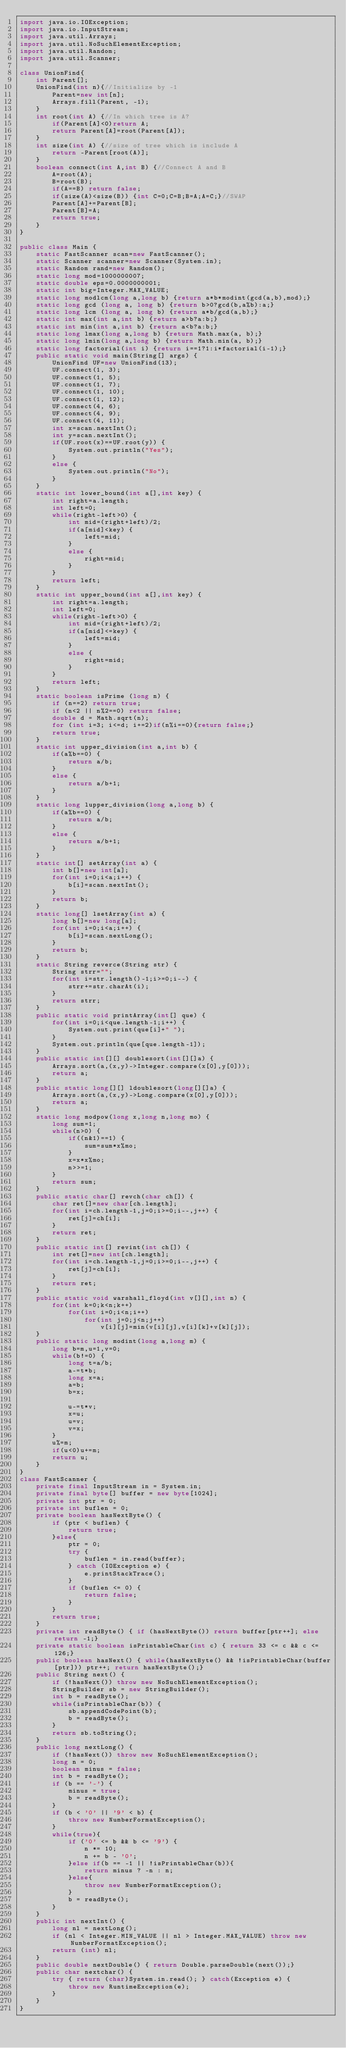<code> <loc_0><loc_0><loc_500><loc_500><_Java_>import java.io.IOException;
import java.io.InputStream;
import java.util.Arrays;
import java.util.NoSuchElementException;
import java.util.Random;
import java.util.Scanner;

class UnionFind{
	int Parent[];
	UnionFind(int n){//Initialize by -1
		Parent=new int[n];
		Arrays.fill(Parent, -1);
	}
	int root(int A) {//In which tree is A?
		if(Parent[A]<0)return A;
		return Parent[A]=root(Parent[A]);
	}
	int size(int A) {//size of tree which is include A
		return -Parent[root(A)];
	}
	boolean connect(int A,int B) {//Connect A and B
		A=root(A);
		B=root(B);
		if(A==B) return false;
		if(size(A)<size(B)) {int C=0;C=B;B=A;A=C;}//SWAP
		Parent[A]+=Parent[B];
		Parent[B]=A;
		return true;
	}
}

public class Main {
	static FastScanner scan=new FastScanner();
	static Scanner scanner=new Scanner(System.in);
	static Random rand=new Random();
	static long mod=1000000007;
	static double eps=0.0000000001;
	static int big=Integer.MAX_VALUE;
	static long modlcm(long a,long b) {return a*b*modint(gcd(a,b),mod);}
	static long gcd (long a, long b) {return b>0?gcd(b,a%b):a;}
	static long lcm (long a, long b) {return a*b/gcd(a,b);}
	static int max(int a,int b) {return a>b?a:b;}
	static int min(int a,int b) {return a<b?a:b;}
	static long lmax(long a,long b) {return Math.max(a, b);}
	static long lmin(long a,long b) {return Math.min(a, b);}
	static long factorial(int i) {return i==1?1:i*factorial(i-1);}
	public static void main(String[] args) {
		UnionFind UF=new UnionFind(13);
		UF.connect(1, 3);
		UF.connect(1, 5);
		UF.connect(1, 7);
		UF.connect(1, 10);
		UF.connect(1, 12);
		UF.connect(4, 6);
		UF.connect(4, 9);
		UF.connect(4, 11);
		int x=scan.nextInt();
		int y=scan.nextInt();
		if(UF.root(x)==UF.root(y)) {
			System.out.println("Yes");
		}
		else {
			System.out.println("No");
		}
	}
	static int lower_bound(int a[],int key) {
		int right=a.length;
		int left=0;
		while(right-left>0) {
			int mid=(right+left)/2;
			if(a[mid]<key) {
				left=mid;
			}
			else {
				right=mid;
			}
		}
		return left;
	}
	static int upper_bound(int a[],int key) {
		int right=a.length;
		int left=0;
		while(right-left>0) {
			int mid=(right+left)/2;
			if(a[mid]<=key) {
				left=mid;
			}
			else {
				right=mid;
			}
		}
		return left;
	}
	static boolean isPrime (long n) {
		if (n==2) return true;
		if (n<2 || n%2==0) return false;
		double d = Math.sqrt(n);
		for (int i=3; i<=d; i+=2)if(n%i==0){return false;}
		return true;
	}
	static int upper_division(int a,int b) {
		if(a%b==0) {
			return a/b;
		}
		else {
			return a/b+1;
		}
	}
	static long lupper_division(long a,long b) {
		if(a%b==0) {
			return a/b;
		}
		else {
			return a/b+1;
		}
	}
	static int[] setArray(int a) {
		int b[]=new int[a];
		for(int i=0;i<a;i++) {
			b[i]=scan.nextInt();
		}
		return b;
	}
	static long[] lsetArray(int a) {
		long b[]=new long[a];
		for(int i=0;i<a;i++) {
			b[i]=scan.nextLong();
		}
		return b;
	}
	static String reverce(String str) {
		String strr="";
		for(int i=str.length()-1;i>=0;i--) {
			strr+=str.charAt(i);
		}
		return strr;
	}
	public static void printArray(int[] que) {
		for(int i=0;i<que.length-1;i++) {
			System.out.print(que[i]+" ");
		}
		System.out.println(que[que.length-1]);
	}
	public static int[][] doublesort(int[][]a) {
		Arrays.sort(a,(x,y)->Integer.compare(x[0],y[0]));
		return a;
	}
	public static long[][] ldoublesort(long[][]a) {
		Arrays.sort(a,(x,y)->Long.compare(x[0],y[0]));
		return a;
	}
	static long modpow(long x,long n,long mo) {
		long sum=1;
		while(n>0) {
			if((n&1)==1) {
				sum=sum*x%mo;
			}
			x=x*x%mo;
			n>>=1;
		}
		return sum;
	}
	public static char[] revch(char ch[]) {
		char ret[]=new char[ch.length];
		for(int i=ch.length-1,j=0;i>=0;i--,j++) {
			ret[j]=ch[i];
		}
		return ret;
	}
	public static int[] revint(int ch[]) {
		int ret[]=new int[ch.length];
		for(int i=ch.length-1,j=0;i>=0;i--,j++) {
			ret[j]=ch[i];
		}
		return ret;
	}
	public static void warshall_floyd(int v[][],int n) {
		for(int k=0;k<n;k++)
			for(int i=0;i<n;i++)
				for(int j=0;j<n;j++)
					v[i][j]=min(v[i][j],v[i][k]+v[k][j]);
	}
	public static long modint(long a,long m) {
		long b=m,u=1,v=0;
		while(b!=0) {
			long t=a/b;
			a-=t*b;
			long x=a;
			a=b;
			b=x;

			u-=t*v;
			x=u;
			u=v;
			v=x;
		}
		u%=m;
		if(u<0)u+=m;
		return u;
	}
}
class FastScanner {
	private final InputStream in = System.in;
	private final byte[] buffer = new byte[1024];
	private int ptr = 0;
	private int buflen = 0;
	private boolean hasNextByte() {
		if (ptr < buflen) {
			return true;
		}else{
			ptr = 0;
			try {
				buflen = in.read(buffer);
			} catch (IOException e) {
				e.printStackTrace();
			}
			if (buflen <= 0) {
				return false;
			}
		}
		return true;
	}
	private int readByte() { if (hasNextByte()) return buffer[ptr++]; else return -1;}
	private static boolean isPrintableChar(int c) { return 33 <= c && c <= 126;}
	public boolean hasNext() { while(hasNextByte() && !isPrintableChar(buffer[ptr])) ptr++; return hasNextByte();}
	public String next() {
		if (!hasNext()) throw new NoSuchElementException();
		StringBuilder sb = new StringBuilder();
		int b = readByte();
		while(isPrintableChar(b)) {
			sb.appendCodePoint(b);
			b = readByte();
		}
		return sb.toString();
	}
	public long nextLong() {
		if (!hasNext()) throw new NoSuchElementException();
		long n = 0;
		boolean minus = false;
		int b = readByte();
		if (b == '-') {
			minus = true;
			b = readByte();
		}
		if (b < '0' || '9' < b) {
			throw new NumberFormatException();
		}
		while(true){
			if ('0' <= b && b <= '9') {
				n *= 10;
				n += b - '0';
			}else if(b == -1 || !isPrintableChar(b)){
				return minus ? -n : n;
			}else{
				throw new NumberFormatException();
			}
			b = readByte();
		}
	}
	public int nextInt() {
		long nl = nextLong();
		if (nl < Integer.MIN_VALUE || nl > Integer.MAX_VALUE) throw new NumberFormatException();
		return (int) nl;
	}
	public double nextDouble() { return Double.parseDouble(next());}
	public char nextchar() {
		try { return (char)System.in.read(); } catch(Exception e) {
			throw new RuntimeException(e);
		}
	}
}
</code> 